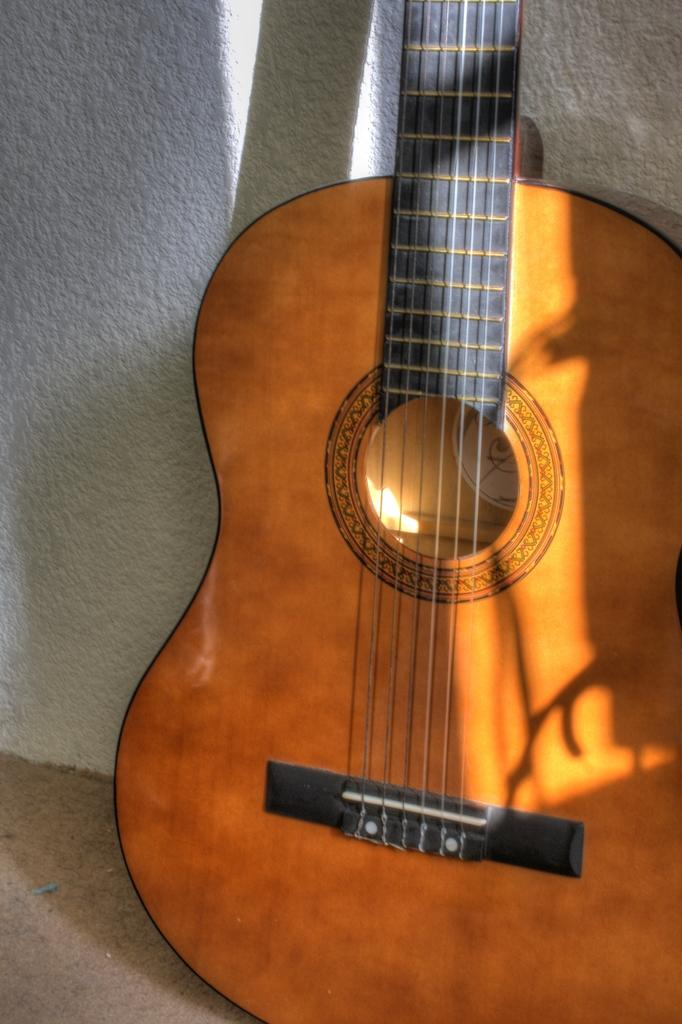What musical instrument is present in the image? There is a guitar with strings in the image. What can be seen in the background of the image? There is a wall in the background of the image. What is the color of the wall in the image? The wall is white in color. What type of truck is parked next to the guitar in the image? There is no truck present in the image; it only a guitar and a white wall are visible. 